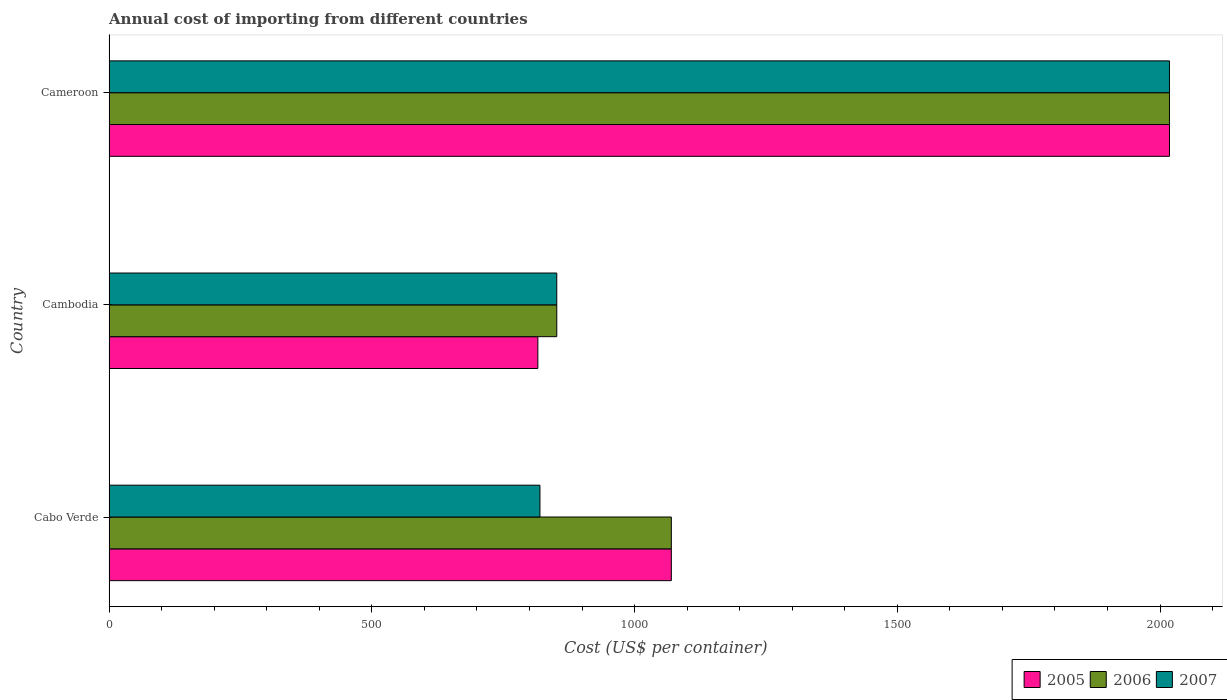How many different coloured bars are there?
Your answer should be very brief. 3. Are the number of bars on each tick of the Y-axis equal?
Provide a succinct answer. Yes. How many bars are there on the 1st tick from the top?
Your answer should be very brief. 3. How many bars are there on the 3rd tick from the bottom?
Offer a terse response. 3. What is the label of the 3rd group of bars from the top?
Offer a very short reply. Cabo Verde. What is the total annual cost of importing in 2007 in Cabo Verde?
Give a very brief answer. 820. Across all countries, what is the maximum total annual cost of importing in 2007?
Provide a succinct answer. 2018. Across all countries, what is the minimum total annual cost of importing in 2005?
Your response must be concise. 816. In which country was the total annual cost of importing in 2007 maximum?
Ensure brevity in your answer.  Cameroon. In which country was the total annual cost of importing in 2007 minimum?
Your answer should be compact. Cabo Verde. What is the total total annual cost of importing in 2007 in the graph?
Keep it short and to the point. 3690. What is the difference between the total annual cost of importing in 2007 in Cabo Verde and that in Cambodia?
Offer a very short reply. -32. What is the difference between the total annual cost of importing in 2007 in Cabo Verde and the total annual cost of importing in 2006 in Cambodia?
Provide a succinct answer. -32. What is the average total annual cost of importing in 2005 per country?
Offer a very short reply. 1301.33. What is the ratio of the total annual cost of importing in 2006 in Cabo Verde to that in Cameroon?
Your answer should be very brief. 0.53. Is the total annual cost of importing in 2007 in Cabo Verde less than that in Cambodia?
Your answer should be very brief. Yes. Is the difference between the total annual cost of importing in 2006 in Cabo Verde and Cambodia greater than the difference between the total annual cost of importing in 2007 in Cabo Verde and Cambodia?
Ensure brevity in your answer.  Yes. What is the difference between the highest and the second highest total annual cost of importing in 2007?
Offer a very short reply. 1166. What is the difference between the highest and the lowest total annual cost of importing in 2007?
Provide a short and direct response. 1198. Is the sum of the total annual cost of importing in 2006 in Cabo Verde and Cambodia greater than the maximum total annual cost of importing in 2005 across all countries?
Provide a short and direct response. No. What does the 3rd bar from the top in Cameroon represents?
Your response must be concise. 2005. What does the 3rd bar from the bottom in Cambodia represents?
Ensure brevity in your answer.  2007. Does the graph contain any zero values?
Provide a succinct answer. No. Does the graph contain grids?
Provide a succinct answer. No. How are the legend labels stacked?
Offer a terse response. Horizontal. What is the title of the graph?
Ensure brevity in your answer.  Annual cost of importing from different countries. Does "1991" appear as one of the legend labels in the graph?
Offer a terse response. No. What is the label or title of the X-axis?
Offer a very short reply. Cost (US$ per container). What is the label or title of the Y-axis?
Offer a very short reply. Country. What is the Cost (US$ per container) of 2005 in Cabo Verde?
Your answer should be very brief. 1070. What is the Cost (US$ per container) of 2006 in Cabo Verde?
Make the answer very short. 1070. What is the Cost (US$ per container) of 2007 in Cabo Verde?
Give a very brief answer. 820. What is the Cost (US$ per container) in 2005 in Cambodia?
Offer a terse response. 816. What is the Cost (US$ per container) of 2006 in Cambodia?
Provide a short and direct response. 852. What is the Cost (US$ per container) in 2007 in Cambodia?
Your answer should be very brief. 852. What is the Cost (US$ per container) of 2005 in Cameroon?
Keep it short and to the point. 2018. What is the Cost (US$ per container) of 2006 in Cameroon?
Provide a succinct answer. 2018. What is the Cost (US$ per container) of 2007 in Cameroon?
Your answer should be very brief. 2018. Across all countries, what is the maximum Cost (US$ per container) in 2005?
Your answer should be very brief. 2018. Across all countries, what is the maximum Cost (US$ per container) of 2006?
Provide a short and direct response. 2018. Across all countries, what is the maximum Cost (US$ per container) of 2007?
Give a very brief answer. 2018. Across all countries, what is the minimum Cost (US$ per container) in 2005?
Offer a terse response. 816. Across all countries, what is the minimum Cost (US$ per container) of 2006?
Give a very brief answer. 852. Across all countries, what is the minimum Cost (US$ per container) of 2007?
Your answer should be compact. 820. What is the total Cost (US$ per container) of 2005 in the graph?
Provide a succinct answer. 3904. What is the total Cost (US$ per container) of 2006 in the graph?
Offer a terse response. 3940. What is the total Cost (US$ per container) in 2007 in the graph?
Ensure brevity in your answer.  3690. What is the difference between the Cost (US$ per container) in 2005 in Cabo Verde and that in Cambodia?
Your response must be concise. 254. What is the difference between the Cost (US$ per container) in 2006 in Cabo Verde and that in Cambodia?
Keep it short and to the point. 218. What is the difference between the Cost (US$ per container) in 2007 in Cabo Verde and that in Cambodia?
Ensure brevity in your answer.  -32. What is the difference between the Cost (US$ per container) in 2005 in Cabo Verde and that in Cameroon?
Offer a terse response. -948. What is the difference between the Cost (US$ per container) of 2006 in Cabo Verde and that in Cameroon?
Give a very brief answer. -948. What is the difference between the Cost (US$ per container) in 2007 in Cabo Verde and that in Cameroon?
Give a very brief answer. -1198. What is the difference between the Cost (US$ per container) in 2005 in Cambodia and that in Cameroon?
Your answer should be compact. -1202. What is the difference between the Cost (US$ per container) in 2006 in Cambodia and that in Cameroon?
Your answer should be very brief. -1166. What is the difference between the Cost (US$ per container) of 2007 in Cambodia and that in Cameroon?
Offer a very short reply. -1166. What is the difference between the Cost (US$ per container) in 2005 in Cabo Verde and the Cost (US$ per container) in 2006 in Cambodia?
Your answer should be very brief. 218. What is the difference between the Cost (US$ per container) of 2005 in Cabo Verde and the Cost (US$ per container) of 2007 in Cambodia?
Ensure brevity in your answer.  218. What is the difference between the Cost (US$ per container) of 2006 in Cabo Verde and the Cost (US$ per container) of 2007 in Cambodia?
Keep it short and to the point. 218. What is the difference between the Cost (US$ per container) of 2005 in Cabo Verde and the Cost (US$ per container) of 2006 in Cameroon?
Your response must be concise. -948. What is the difference between the Cost (US$ per container) in 2005 in Cabo Verde and the Cost (US$ per container) in 2007 in Cameroon?
Keep it short and to the point. -948. What is the difference between the Cost (US$ per container) of 2006 in Cabo Verde and the Cost (US$ per container) of 2007 in Cameroon?
Provide a succinct answer. -948. What is the difference between the Cost (US$ per container) in 2005 in Cambodia and the Cost (US$ per container) in 2006 in Cameroon?
Keep it short and to the point. -1202. What is the difference between the Cost (US$ per container) in 2005 in Cambodia and the Cost (US$ per container) in 2007 in Cameroon?
Your response must be concise. -1202. What is the difference between the Cost (US$ per container) of 2006 in Cambodia and the Cost (US$ per container) of 2007 in Cameroon?
Provide a short and direct response. -1166. What is the average Cost (US$ per container) of 2005 per country?
Ensure brevity in your answer.  1301.33. What is the average Cost (US$ per container) in 2006 per country?
Offer a terse response. 1313.33. What is the average Cost (US$ per container) in 2007 per country?
Your response must be concise. 1230. What is the difference between the Cost (US$ per container) in 2005 and Cost (US$ per container) in 2007 in Cabo Verde?
Offer a very short reply. 250. What is the difference between the Cost (US$ per container) in 2006 and Cost (US$ per container) in 2007 in Cabo Verde?
Offer a terse response. 250. What is the difference between the Cost (US$ per container) in 2005 and Cost (US$ per container) in 2006 in Cambodia?
Offer a terse response. -36. What is the difference between the Cost (US$ per container) of 2005 and Cost (US$ per container) of 2007 in Cambodia?
Ensure brevity in your answer.  -36. What is the difference between the Cost (US$ per container) of 2006 and Cost (US$ per container) of 2007 in Cambodia?
Provide a short and direct response. 0. What is the ratio of the Cost (US$ per container) of 2005 in Cabo Verde to that in Cambodia?
Provide a short and direct response. 1.31. What is the ratio of the Cost (US$ per container) in 2006 in Cabo Verde to that in Cambodia?
Your answer should be very brief. 1.26. What is the ratio of the Cost (US$ per container) in 2007 in Cabo Verde to that in Cambodia?
Keep it short and to the point. 0.96. What is the ratio of the Cost (US$ per container) of 2005 in Cabo Verde to that in Cameroon?
Your response must be concise. 0.53. What is the ratio of the Cost (US$ per container) in 2006 in Cabo Verde to that in Cameroon?
Offer a very short reply. 0.53. What is the ratio of the Cost (US$ per container) in 2007 in Cabo Verde to that in Cameroon?
Give a very brief answer. 0.41. What is the ratio of the Cost (US$ per container) in 2005 in Cambodia to that in Cameroon?
Provide a succinct answer. 0.4. What is the ratio of the Cost (US$ per container) in 2006 in Cambodia to that in Cameroon?
Make the answer very short. 0.42. What is the ratio of the Cost (US$ per container) in 2007 in Cambodia to that in Cameroon?
Offer a terse response. 0.42. What is the difference between the highest and the second highest Cost (US$ per container) of 2005?
Your response must be concise. 948. What is the difference between the highest and the second highest Cost (US$ per container) in 2006?
Offer a very short reply. 948. What is the difference between the highest and the second highest Cost (US$ per container) of 2007?
Provide a succinct answer. 1166. What is the difference between the highest and the lowest Cost (US$ per container) of 2005?
Keep it short and to the point. 1202. What is the difference between the highest and the lowest Cost (US$ per container) in 2006?
Make the answer very short. 1166. What is the difference between the highest and the lowest Cost (US$ per container) of 2007?
Offer a terse response. 1198. 